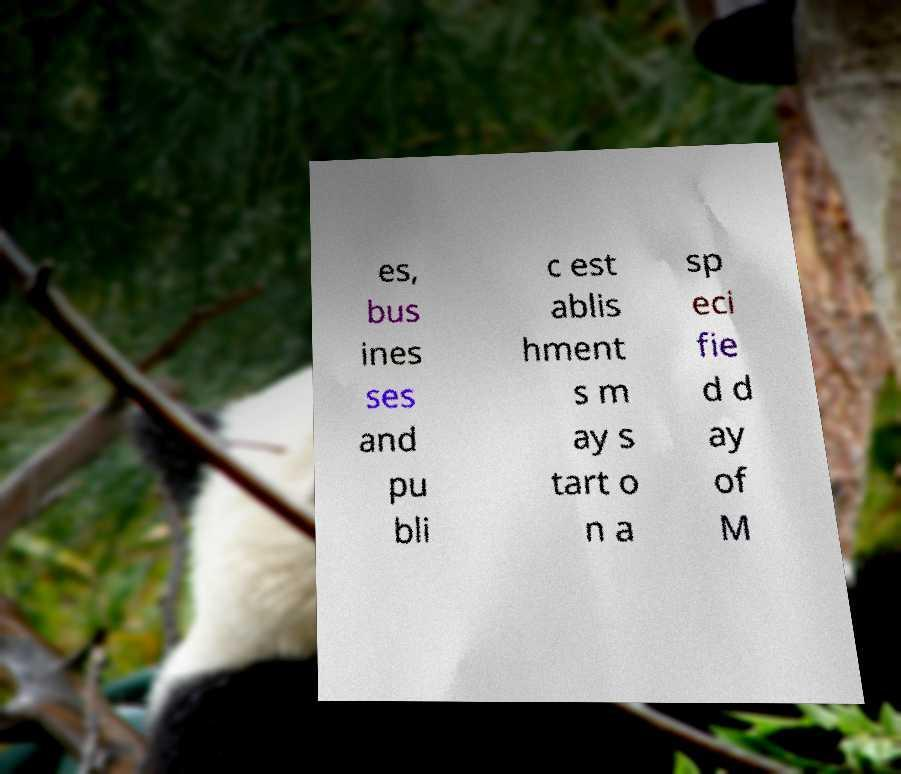There's text embedded in this image that I need extracted. Can you transcribe it verbatim? es, bus ines ses and pu bli c est ablis hment s m ay s tart o n a sp eci fie d d ay of M 